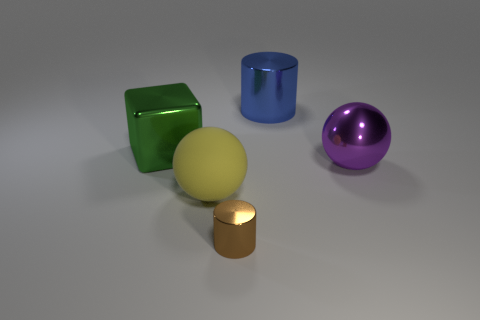Add 2 large shiny objects. How many objects exist? 7 Subtract all spheres. How many objects are left? 3 Add 5 large blue metal objects. How many large blue metal objects exist? 6 Subtract 0 brown cubes. How many objects are left? 5 Subtract all red metal spheres. Subtract all large purple spheres. How many objects are left? 4 Add 4 large yellow matte spheres. How many large yellow matte spheres are left? 5 